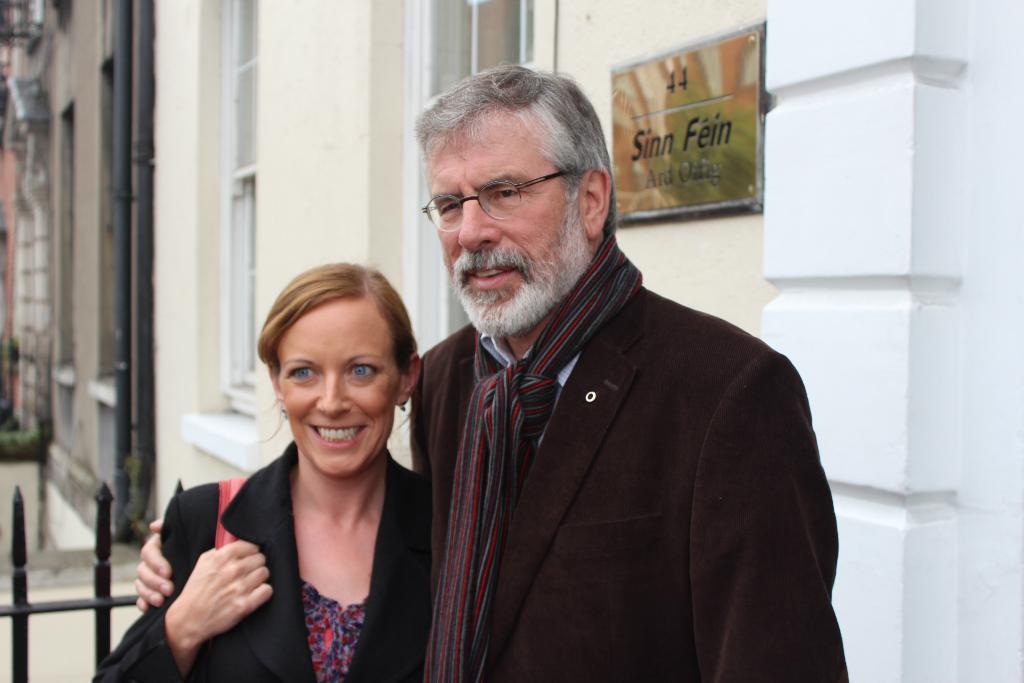Can you describe this image briefly? In this image, in the middle, we can see two people man and woman. On the right side, we can see a frame which is attached to a wall, we can also see a wall which is in white color. In the background, we can see a metal pole, pipes, buildings, glass window. 